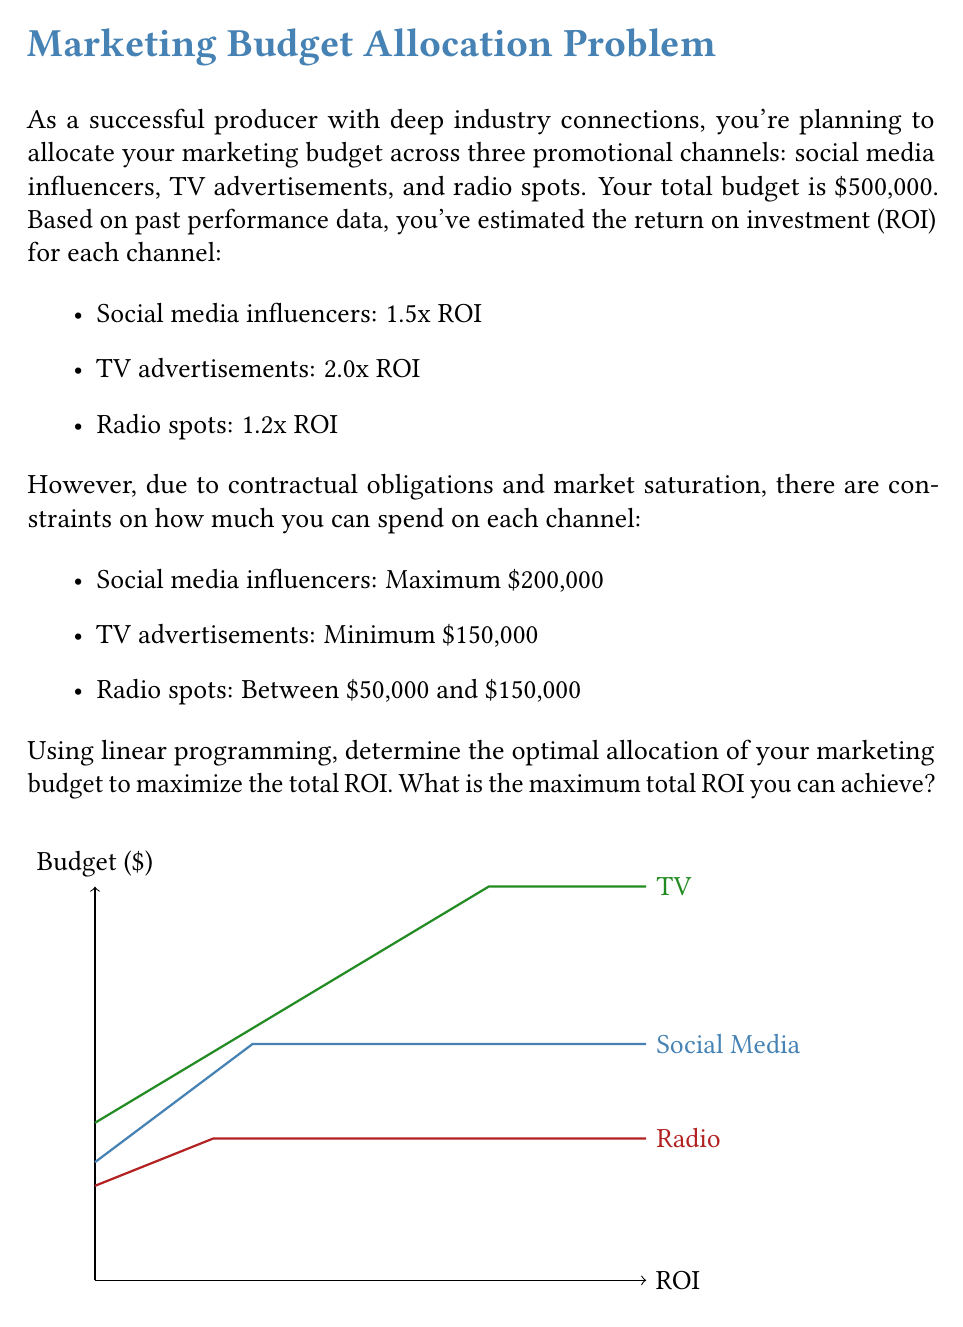Give your solution to this math problem. Let's solve this step-by-step using linear programming:

1) Define variables:
   Let $x$ = amount spent on social media influencers
   Let $y$ = amount spent on TV advertisements
   Let $z$ = amount spent on radio spots

2) Objective function (to maximize):
   $\text{ROI} = 1.5x + 2.0y + 1.2z$

3) Constraints:
   $x + y + z \leq 500,000$ (total budget)
   $x \leq 200,000$ (social media max)
   $y \geq 150,000$ (TV min)
   $50,000 \leq z \leq 150,000$ (radio range)
   $x, y, z \geq 0$ (non-negativity)

4) Solve using the simplex method or linear programming software. The optimal solution is:
   $x = 200,000$
   $y = 250,000$
   $z = 50,000$

5) Calculate the maximum ROI:
   $\text{ROI} = 1.5(200,000) + 2.0(250,000) + 1.2(50,000)$
   $= 300,000 + 500,000 + 60,000$
   $= 860,000$

Therefore, the maximum total ROI achievable is $860,000.
Answer: $860,000 